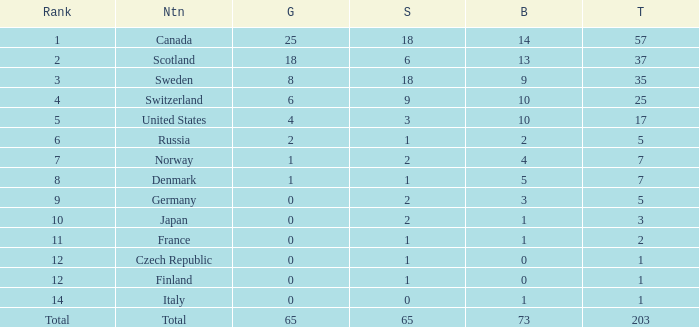What is the total number of medals when there are 18 gold medals? 37.0. 